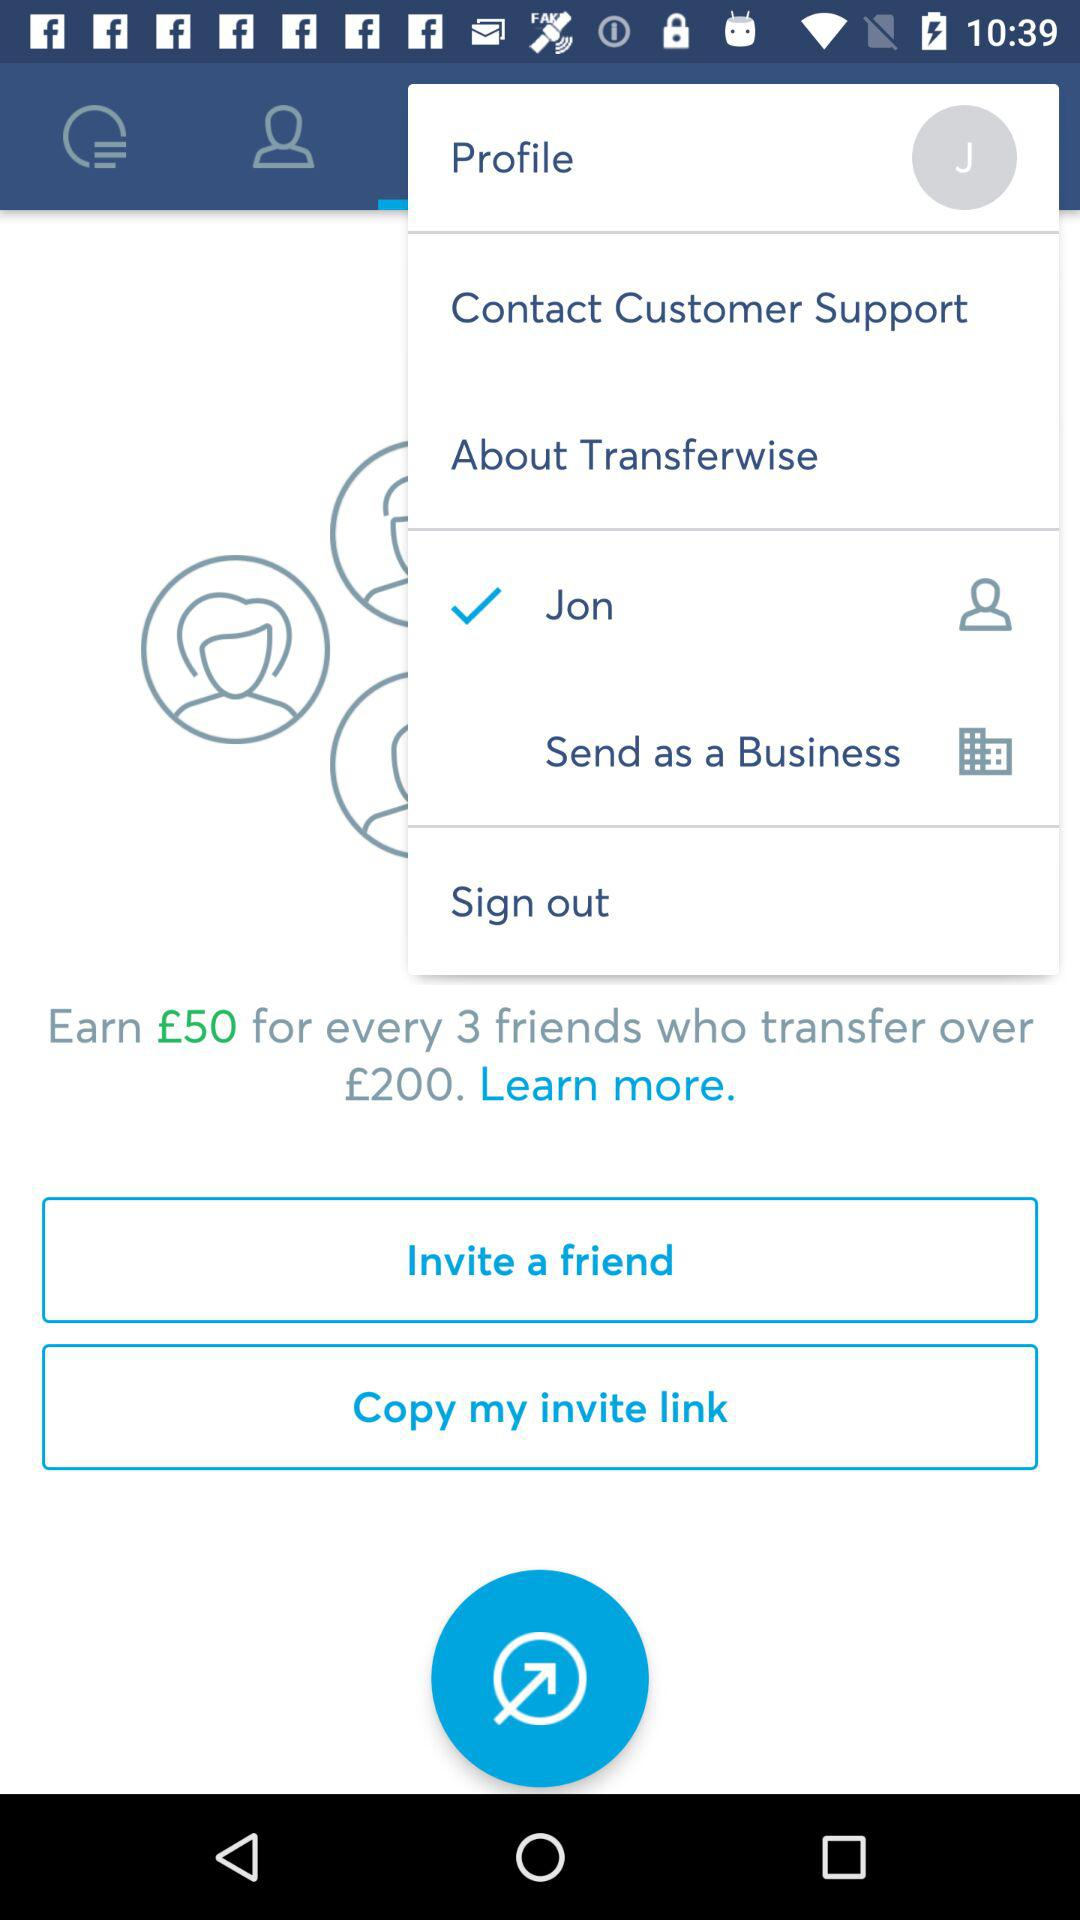How much do we earn for each of our three friends? You can earn £50 for each of your three friends. 